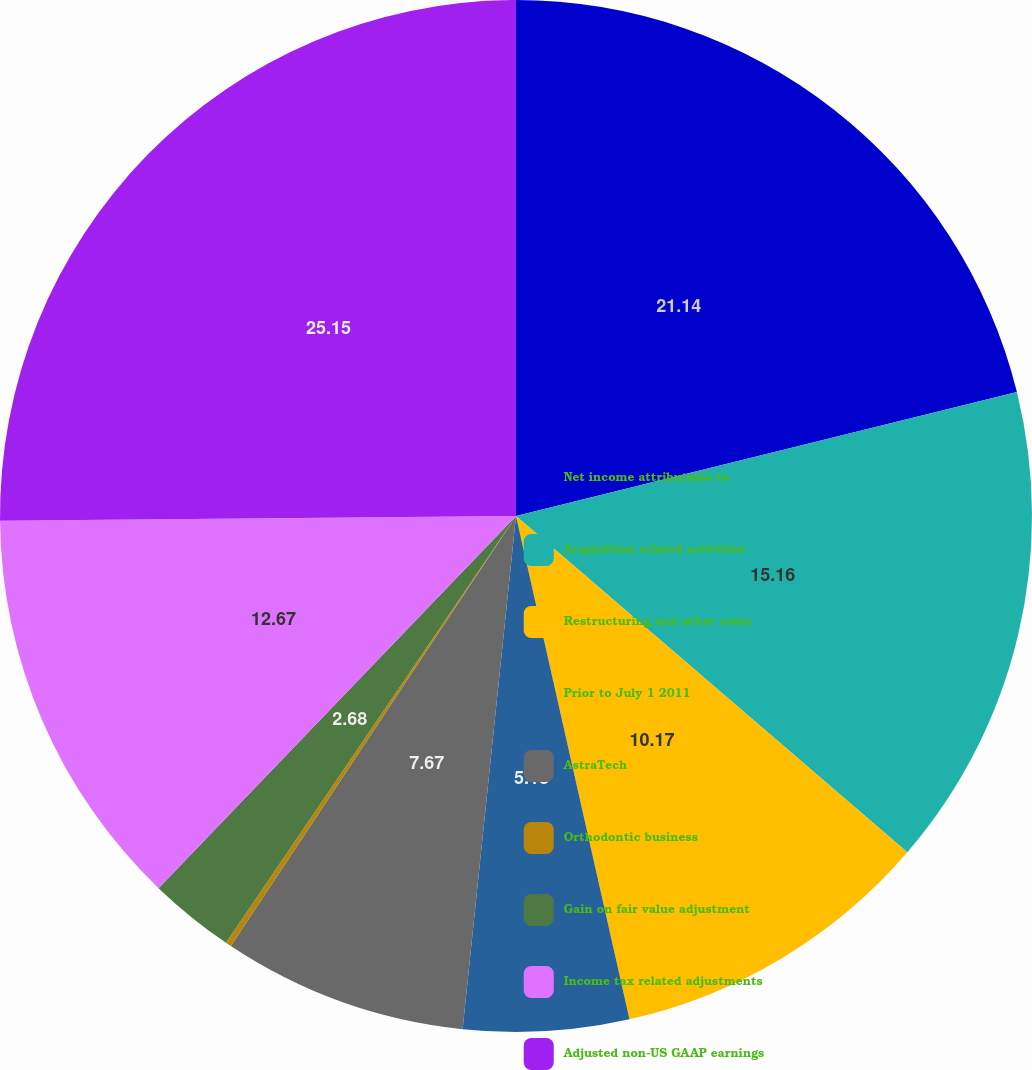Convert chart. <chart><loc_0><loc_0><loc_500><loc_500><pie_chart><fcel>Net income attributable to<fcel>Acquisition related activities<fcel>Restructuring and other costs<fcel>Prior to July 1 2011<fcel>AstraTech<fcel>Orthodontic business<fcel>Gain on fair value adjustment<fcel>Income tax related adjustments<fcel>Adjusted non-US GAAP earnings<nl><fcel>21.14%<fcel>15.16%<fcel>10.17%<fcel>5.18%<fcel>7.67%<fcel>0.18%<fcel>2.68%<fcel>12.67%<fcel>25.15%<nl></chart> 